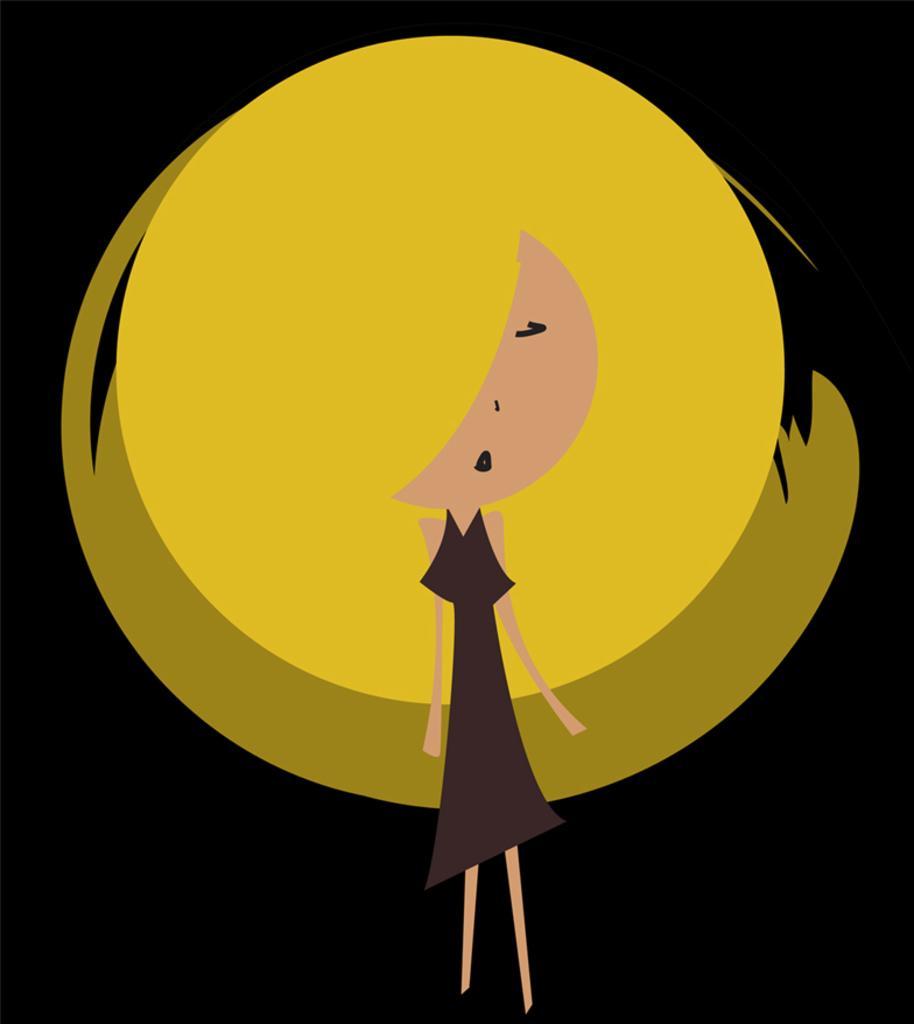Can you describe this image briefly? In this image there is an animated picture. In the center there is a girl. Behind her there are yellow circles. The background is dark. 